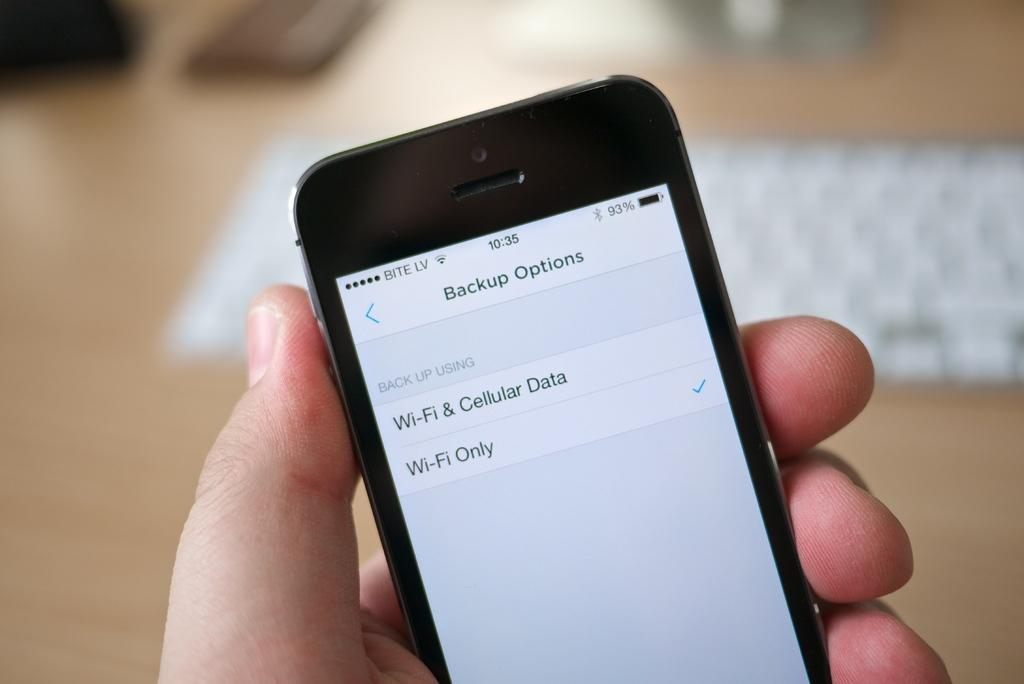<image>
Describe the image concisely. A phone that reads 10:35 is showing a list of Backup Options. 